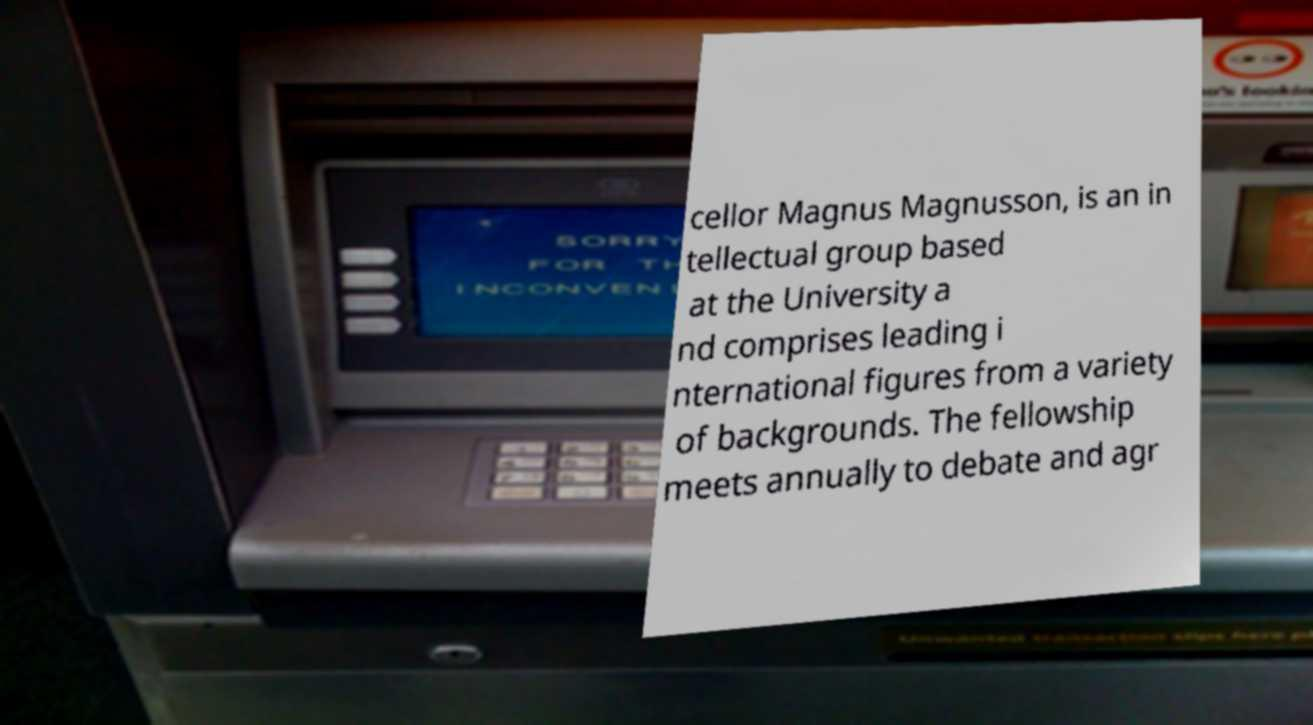I need the written content from this picture converted into text. Can you do that? cellor Magnus Magnusson, is an in tellectual group based at the University a nd comprises leading i nternational figures from a variety of backgrounds. The fellowship meets annually to debate and agr 